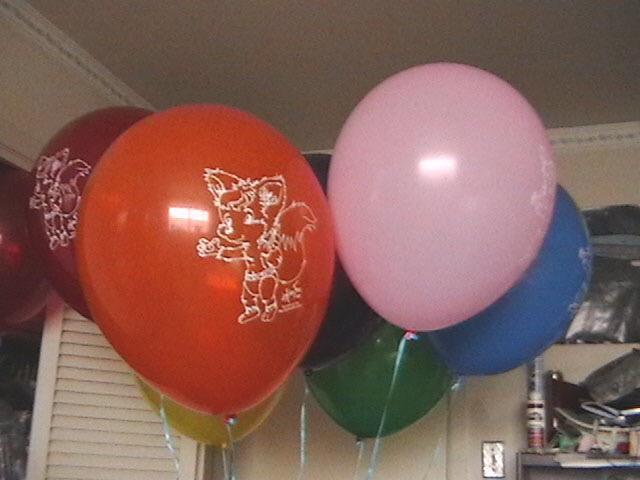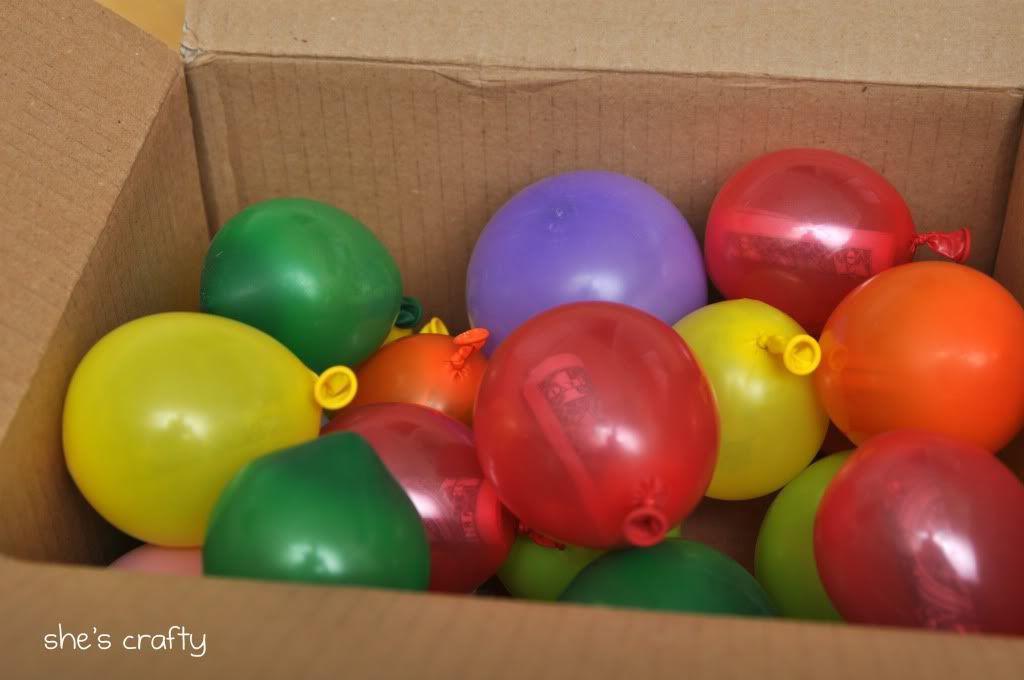The first image is the image on the left, the second image is the image on the right. Analyze the images presented: Is the assertion "Several balloons are in the air in the left image, and at least a dozen balloons are in a container with sides in the right image." valid? Answer yes or no. Yes. 